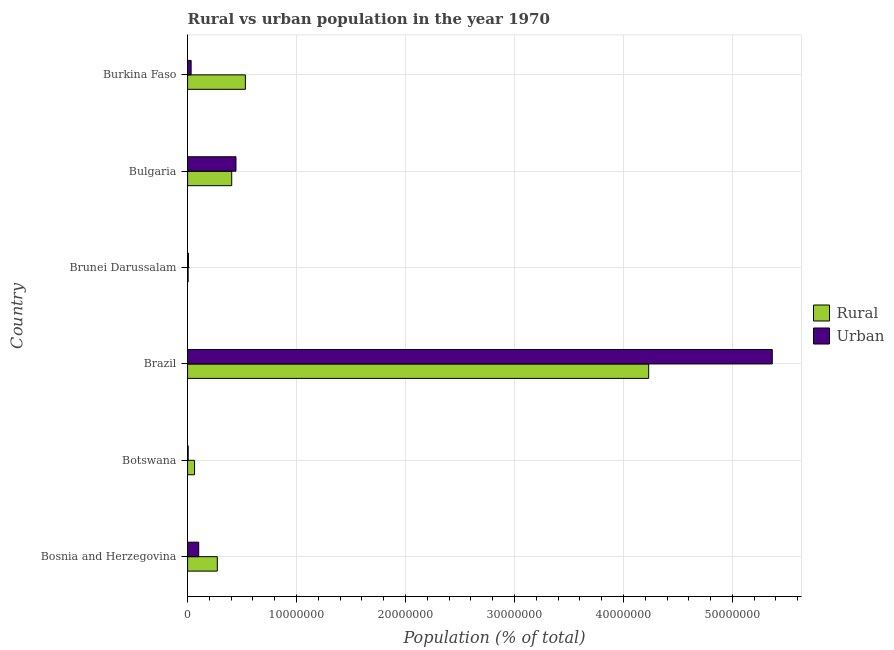Are the number of bars per tick equal to the number of legend labels?
Provide a short and direct response. Yes. What is the rural population density in Burkina Faso?
Provide a short and direct response. 5.30e+06. Across all countries, what is the maximum rural population density?
Your answer should be compact. 4.23e+07. Across all countries, what is the minimum urban population density?
Keep it short and to the point. 5.43e+04. In which country was the urban population density maximum?
Provide a short and direct response. Brazil. In which country was the urban population density minimum?
Provide a succinct answer. Botswana. What is the total rural population density in the graph?
Your answer should be very brief. 5.51e+07. What is the difference between the rural population density in Brunei Darussalam and that in Burkina Faso?
Provide a succinct answer. -5.25e+06. What is the difference between the rural population density in Botswana and the urban population density in Burkina Faso?
Your response must be concise. 3.16e+05. What is the average rural population density per country?
Your answer should be compact. 9.18e+06. What is the difference between the urban population density and rural population density in Brunei Darussalam?
Make the answer very short. 3.03e+04. In how many countries, is the urban population density greater than 44000000 %?
Provide a succinct answer. 1. What is the ratio of the rural population density in Botswana to that in Bulgaria?
Your answer should be compact. 0.16. Is the urban population density in Brazil less than that in Bulgaria?
Your response must be concise. No. Is the difference between the urban population density in Bosnia and Herzegovina and Botswana greater than the difference between the rural population density in Bosnia and Herzegovina and Botswana?
Provide a succinct answer. No. What is the difference between the highest and the second highest rural population density?
Offer a terse response. 3.70e+07. What is the difference between the highest and the lowest rural population density?
Offer a very short reply. 4.23e+07. Is the sum of the rural population density in Bulgaria and Burkina Faso greater than the maximum urban population density across all countries?
Provide a succinct answer. No. What does the 1st bar from the top in Botswana represents?
Ensure brevity in your answer.  Urban. What does the 2nd bar from the bottom in Bulgaria represents?
Your response must be concise. Urban. How many bars are there?
Keep it short and to the point. 12. What is the difference between two consecutive major ticks on the X-axis?
Make the answer very short. 1.00e+07. Are the values on the major ticks of X-axis written in scientific E-notation?
Your answer should be compact. No. Does the graph contain any zero values?
Your response must be concise. No. Does the graph contain grids?
Keep it short and to the point. Yes. How many legend labels are there?
Keep it short and to the point. 2. How are the legend labels stacked?
Provide a short and direct response. Vertical. What is the title of the graph?
Make the answer very short. Rural vs urban population in the year 1970. Does "Technicians" appear as one of the legend labels in the graph?
Ensure brevity in your answer.  No. What is the label or title of the X-axis?
Make the answer very short. Population (% of total). What is the Population (% of total) in Rural in Bosnia and Herzegovina?
Provide a succinct answer. 2.73e+06. What is the Population (% of total) of Urban in Bosnia and Herzegovina?
Keep it short and to the point. 1.02e+06. What is the Population (% of total) of Rural in Botswana?
Your answer should be very brief. 6.39e+05. What is the Population (% of total) of Urban in Botswana?
Your answer should be compact. 5.43e+04. What is the Population (% of total) of Rural in Brazil?
Keep it short and to the point. 4.23e+07. What is the Population (% of total) in Urban in Brazil?
Keep it short and to the point. 5.37e+07. What is the Population (% of total) of Rural in Brunei Darussalam?
Offer a very short reply. 4.97e+04. What is the Population (% of total) in Urban in Brunei Darussalam?
Your answer should be compact. 8.00e+04. What is the Population (% of total) of Rural in Bulgaria?
Provide a short and direct response. 4.05e+06. What is the Population (% of total) in Urban in Bulgaria?
Provide a succinct answer. 4.44e+06. What is the Population (% of total) in Rural in Burkina Faso?
Offer a very short reply. 5.30e+06. What is the Population (% of total) in Urban in Burkina Faso?
Keep it short and to the point. 3.23e+05. Across all countries, what is the maximum Population (% of total) in Rural?
Your response must be concise. 4.23e+07. Across all countries, what is the maximum Population (% of total) of Urban?
Your answer should be very brief. 5.37e+07. Across all countries, what is the minimum Population (% of total) of Rural?
Your answer should be compact. 4.97e+04. Across all countries, what is the minimum Population (% of total) in Urban?
Provide a succinct answer. 5.43e+04. What is the total Population (% of total) of Rural in the graph?
Your answer should be compact. 5.51e+07. What is the total Population (% of total) in Urban in the graph?
Ensure brevity in your answer.  5.96e+07. What is the difference between the Population (% of total) in Rural in Bosnia and Herzegovina and that in Botswana?
Make the answer very short. 2.09e+06. What is the difference between the Population (% of total) of Urban in Bosnia and Herzegovina and that in Botswana?
Your response must be concise. 9.65e+05. What is the difference between the Population (% of total) in Rural in Bosnia and Herzegovina and that in Brazil?
Offer a very short reply. -3.96e+07. What is the difference between the Population (% of total) in Urban in Bosnia and Herzegovina and that in Brazil?
Your answer should be compact. -5.26e+07. What is the difference between the Population (% of total) of Rural in Bosnia and Herzegovina and that in Brunei Darussalam?
Offer a terse response. 2.68e+06. What is the difference between the Population (% of total) of Urban in Bosnia and Herzegovina and that in Brunei Darussalam?
Offer a very short reply. 9.39e+05. What is the difference between the Population (% of total) of Rural in Bosnia and Herzegovina and that in Bulgaria?
Give a very brief answer. -1.32e+06. What is the difference between the Population (% of total) in Urban in Bosnia and Herzegovina and that in Bulgaria?
Provide a short and direct response. -3.42e+06. What is the difference between the Population (% of total) of Rural in Bosnia and Herzegovina and that in Burkina Faso?
Offer a very short reply. -2.57e+06. What is the difference between the Population (% of total) of Urban in Bosnia and Herzegovina and that in Burkina Faso?
Your response must be concise. 6.96e+05. What is the difference between the Population (% of total) of Rural in Botswana and that in Brazil?
Offer a terse response. -4.17e+07. What is the difference between the Population (% of total) of Urban in Botswana and that in Brazil?
Ensure brevity in your answer.  -5.36e+07. What is the difference between the Population (% of total) in Rural in Botswana and that in Brunei Darussalam?
Your answer should be very brief. 5.89e+05. What is the difference between the Population (% of total) of Urban in Botswana and that in Brunei Darussalam?
Provide a succinct answer. -2.57e+04. What is the difference between the Population (% of total) of Rural in Botswana and that in Bulgaria?
Ensure brevity in your answer.  -3.41e+06. What is the difference between the Population (% of total) of Urban in Botswana and that in Bulgaria?
Provide a short and direct response. -4.39e+06. What is the difference between the Population (% of total) of Rural in Botswana and that in Burkina Faso?
Keep it short and to the point. -4.66e+06. What is the difference between the Population (% of total) in Urban in Botswana and that in Burkina Faso?
Your answer should be compact. -2.69e+05. What is the difference between the Population (% of total) of Rural in Brazil and that in Brunei Darussalam?
Make the answer very short. 4.23e+07. What is the difference between the Population (% of total) in Urban in Brazil and that in Brunei Darussalam?
Give a very brief answer. 5.36e+07. What is the difference between the Population (% of total) of Rural in Brazil and that in Bulgaria?
Make the answer very short. 3.83e+07. What is the difference between the Population (% of total) of Urban in Brazil and that in Bulgaria?
Ensure brevity in your answer.  4.92e+07. What is the difference between the Population (% of total) in Rural in Brazil and that in Burkina Faso?
Your response must be concise. 3.70e+07. What is the difference between the Population (% of total) in Urban in Brazil and that in Burkina Faso?
Your response must be concise. 5.33e+07. What is the difference between the Population (% of total) in Rural in Brunei Darussalam and that in Bulgaria?
Make the answer very short. -4.00e+06. What is the difference between the Population (% of total) in Urban in Brunei Darussalam and that in Bulgaria?
Make the answer very short. -4.36e+06. What is the difference between the Population (% of total) in Rural in Brunei Darussalam and that in Burkina Faso?
Give a very brief answer. -5.25e+06. What is the difference between the Population (% of total) of Urban in Brunei Darussalam and that in Burkina Faso?
Provide a short and direct response. -2.43e+05. What is the difference between the Population (% of total) in Rural in Bulgaria and that in Burkina Faso?
Provide a short and direct response. -1.25e+06. What is the difference between the Population (% of total) of Urban in Bulgaria and that in Burkina Faso?
Make the answer very short. 4.12e+06. What is the difference between the Population (% of total) in Rural in Bosnia and Herzegovina and the Population (% of total) in Urban in Botswana?
Your answer should be very brief. 2.67e+06. What is the difference between the Population (% of total) in Rural in Bosnia and Herzegovina and the Population (% of total) in Urban in Brazil?
Provide a succinct answer. -5.09e+07. What is the difference between the Population (% of total) of Rural in Bosnia and Herzegovina and the Population (% of total) of Urban in Brunei Darussalam?
Your answer should be compact. 2.65e+06. What is the difference between the Population (% of total) in Rural in Bosnia and Herzegovina and the Population (% of total) in Urban in Bulgaria?
Your answer should be very brief. -1.71e+06. What is the difference between the Population (% of total) of Rural in Bosnia and Herzegovina and the Population (% of total) of Urban in Burkina Faso?
Make the answer very short. 2.40e+06. What is the difference between the Population (% of total) in Rural in Botswana and the Population (% of total) in Urban in Brazil?
Keep it short and to the point. -5.30e+07. What is the difference between the Population (% of total) in Rural in Botswana and the Population (% of total) in Urban in Brunei Darussalam?
Ensure brevity in your answer.  5.59e+05. What is the difference between the Population (% of total) of Rural in Botswana and the Population (% of total) of Urban in Bulgaria?
Your answer should be compact. -3.80e+06. What is the difference between the Population (% of total) in Rural in Botswana and the Population (% of total) in Urban in Burkina Faso?
Offer a very short reply. 3.16e+05. What is the difference between the Population (% of total) in Rural in Brazil and the Population (% of total) in Urban in Brunei Darussalam?
Make the answer very short. 4.22e+07. What is the difference between the Population (% of total) of Rural in Brazil and the Population (% of total) of Urban in Bulgaria?
Your answer should be compact. 3.79e+07. What is the difference between the Population (% of total) of Rural in Brazil and the Population (% of total) of Urban in Burkina Faso?
Provide a succinct answer. 4.20e+07. What is the difference between the Population (% of total) of Rural in Brunei Darussalam and the Population (% of total) of Urban in Bulgaria?
Ensure brevity in your answer.  -4.39e+06. What is the difference between the Population (% of total) in Rural in Brunei Darussalam and the Population (% of total) in Urban in Burkina Faso?
Give a very brief answer. -2.73e+05. What is the difference between the Population (% of total) of Rural in Bulgaria and the Population (% of total) of Urban in Burkina Faso?
Your response must be concise. 3.73e+06. What is the average Population (% of total) of Rural per country?
Offer a very short reply. 9.18e+06. What is the average Population (% of total) of Urban per country?
Ensure brevity in your answer.  9.93e+06. What is the difference between the Population (% of total) of Rural and Population (% of total) of Urban in Bosnia and Herzegovina?
Offer a terse response. 1.71e+06. What is the difference between the Population (% of total) in Rural and Population (% of total) in Urban in Botswana?
Offer a terse response. 5.84e+05. What is the difference between the Population (% of total) in Rural and Population (% of total) in Urban in Brazil?
Ensure brevity in your answer.  -1.13e+07. What is the difference between the Population (% of total) in Rural and Population (% of total) in Urban in Brunei Darussalam?
Your response must be concise. -3.03e+04. What is the difference between the Population (% of total) in Rural and Population (% of total) in Urban in Bulgaria?
Keep it short and to the point. -3.91e+05. What is the difference between the Population (% of total) of Rural and Population (% of total) of Urban in Burkina Faso?
Offer a terse response. 4.98e+06. What is the ratio of the Population (% of total) of Rural in Bosnia and Herzegovina to that in Botswana?
Offer a terse response. 4.27. What is the ratio of the Population (% of total) in Urban in Bosnia and Herzegovina to that in Botswana?
Provide a short and direct response. 18.77. What is the ratio of the Population (% of total) in Rural in Bosnia and Herzegovina to that in Brazil?
Your response must be concise. 0.06. What is the ratio of the Population (% of total) of Urban in Bosnia and Herzegovina to that in Brazil?
Offer a very short reply. 0.02. What is the ratio of the Population (% of total) of Rural in Bosnia and Herzegovina to that in Brunei Darussalam?
Offer a very short reply. 54.84. What is the ratio of the Population (% of total) in Urban in Bosnia and Herzegovina to that in Brunei Darussalam?
Make the answer very short. 12.73. What is the ratio of the Population (% of total) in Rural in Bosnia and Herzegovina to that in Bulgaria?
Ensure brevity in your answer.  0.67. What is the ratio of the Population (% of total) in Urban in Bosnia and Herzegovina to that in Bulgaria?
Offer a terse response. 0.23. What is the ratio of the Population (% of total) in Rural in Bosnia and Herzegovina to that in Burkina Faso?
Your answer should be compact. 0.51. What is the ratio of the Population (% of total) of Urban in Bosnia and Herzegovina to that in Burkina Faso?
Offer a terse response. 3.15. What is the ratio of the Population (% of total) of Rural in Botswana to that in Brazil?
Your response must be concise. 0.02. What is the ratio of the Population (% of total) in Rural in Botswana to that in Brunei Darussalam?
Ensure brevity in your answer.  12.85. What is the ratio of the Population (% of total) in Urban in Botswana to that in Brunei Darussalam?
Offer a terse response. 0.68. What is the ratio of the Population (% of total) of Rural in Botswana to that in Bulgaria?
Give a very brief answer. 0.16. What is the ratio of the Population (% of total) of Urban in Botswana to that in Bulgaria?
Keep it short and to the point. 0.01. What is the ratio of the Population (% of total) in Rural in Botswana to that in Burkina Faso?
Your answer should be compact. 0.12. What is the ratio of the Population (% of total) in Urban in Botswana to that in Burkina Faso?
Your answer should be compact. 0.17. What is the ratio of the Population (% of total) in Rural in Brazil to that in Brunei Darussalam?
Provide a short and direct response. 851.18. What is the ratio of the Population (% of total) of Urban in Brazil to that in Brunei Darussalam?
Provide a short and direct response. 670.7. What is the ratio of the Population (% of total) in Rural in Brazil to that in Bulgaria?
Provide a short and direct response. 10.45. What is the ratio of the Population (% of total) in Urban in Brazil to that in Bulgaria?
Provide a short and direct response. 12.09. What is the ratio of the Population (% of total) of Rural in Brazil to that in Burkina Faso?
Provide a short and direct response. 7.98. What is the ratio of the Population (% of total) of Urban in Brazil to that in Burkina Faso?
Your response must be concise. 166.04. What is the ratio of the Population (% of total) in Rural in Brunei Darussalam to that in Bulgaria?
Offer a terse response. 0.01. What is the ratio of the Population (% of total) in Urban in Brunei Darussalam to that in Bulgaria?
Your response must be concise. 0.02. What is the ratio of the Population (% of total) in Rural in Brunei Darussalam to that in Burkina Faso?
Offer a terse response. 0.01. What is the ratio of the Population (% of total) of Urban in Brunei Darussalam to that in Burkina Faso?
Make the answer very short. 0.25. What is the ratio of the Population (% of total) of Rural in Bulgaria to that in Burkina Faso?
Give a very brief answer. 0.76. What is the ratio of the Population (% of total) of Urban in Bulgaria to that in Burkina Faso?
Provide a short and direct response. 13.74. What is the difference between the highest and the second highest Population (% of total) in Rural?
Provide a succinct answer. 3.70e+07. What is the difference between the highest and the second highest Population (% of total) in Urban?
Make the answer very short. 4.92e+07. What is the difference between the highest and the lowest Population (% of total) of Rural?
Provide a succinct answer. 4.23e+07. What is the difference between the highest and the lowest Population (% of total) in Urban?
Provide a short and direct response. 5.36e+07. 